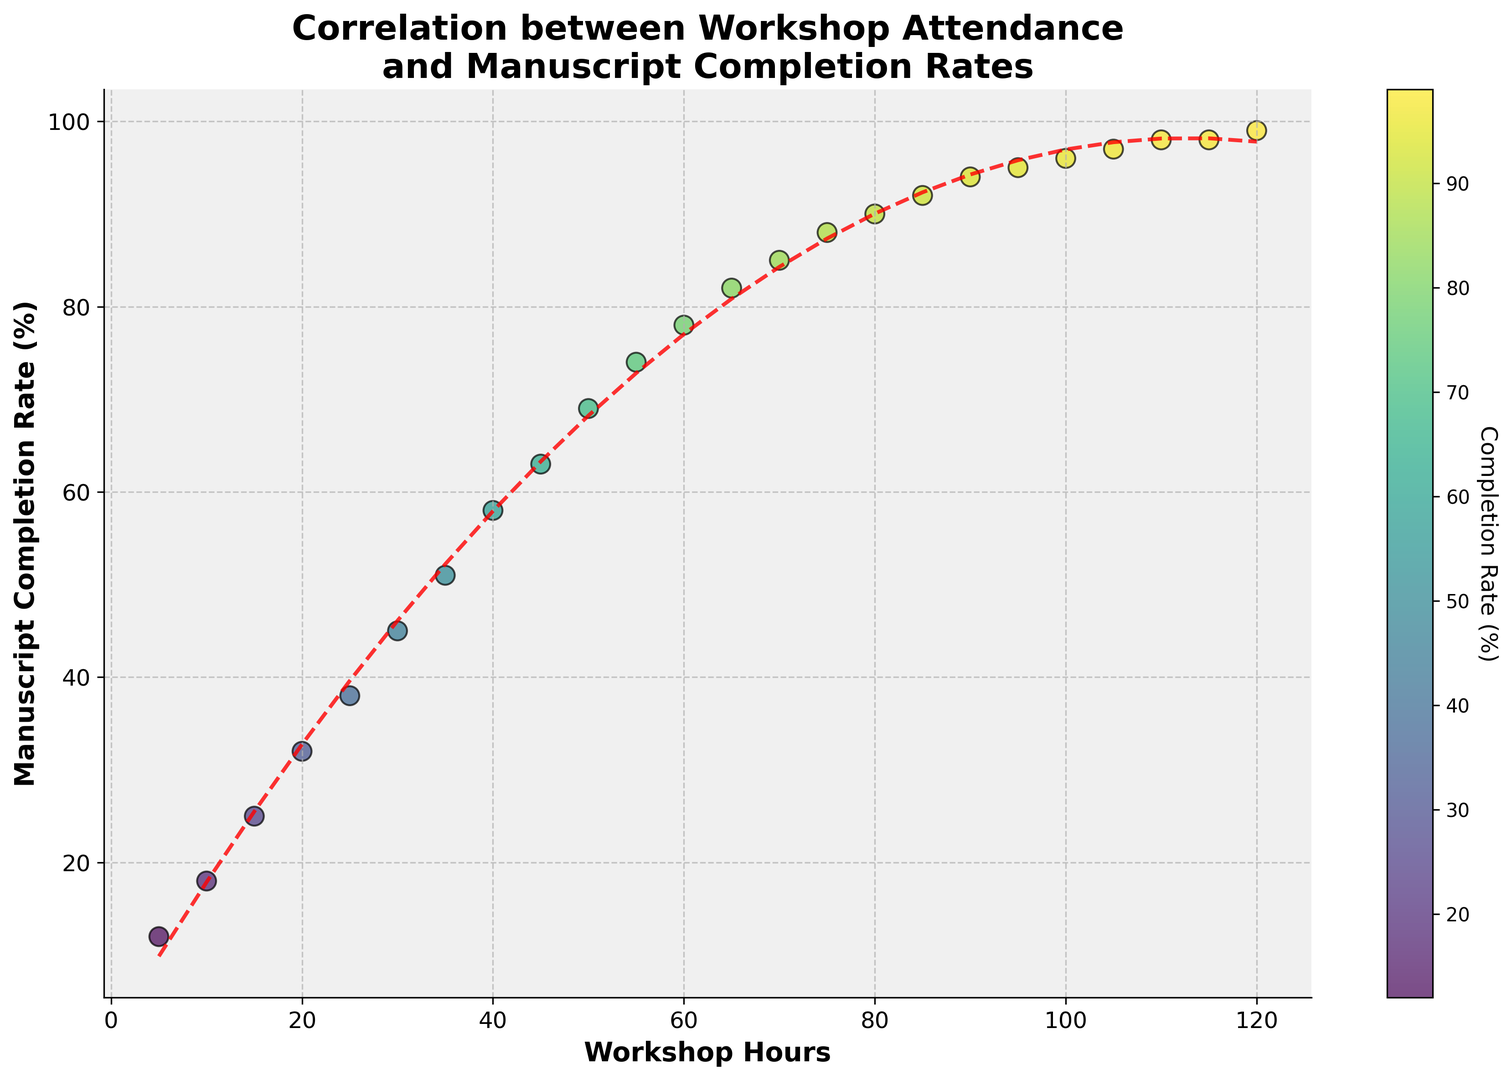What is the general trend shown in the scatter plot? The scatter plot shows that as workshop hours increase, the manuscript completion rate also increases. This is evidenced by the upward trend in both the scatter points and the fitted curve.
Answer: Positive correlation At what workshop hours does the manuscript completion rate first reach 90%? By looking at the scatter plot, the manuscript completion rate first reaches 90% at 80 workshop hours. This can be identified by finding the corresponding y-axis value on the graph.
Answer: 80 hours What is the difference in manuscript completion rates between attending 70 and 90 workshop hours? At 70 workshop hours, the completion rate is 85%, and at 90 hours, it is 94%. The difference is calculated by subtracting the two rates: 94% - 85% = 9%.
Answer: 9% How does the rate of increase in manuscript completion change as workshop hours increase? The increase in completion rates starts to slow down after a certain point, showing a diminishing return on additional workshop hours. This is evident from the flattening of the fitted curve as workshop hours exceed around 80-90 hours.
Answer: Slows down Which data point has the highest manuscript completion rate? The highest manuscript completion rate is 99%, which is achieved at 120 workshop hours. This can be found by identifying the highest y-value on the scatter plot.
Answer: 120 hours By attending an additional 60 hours of workshops, how much does the manuscript completion rate improve (from 5 to 65 hours)? At 5 hours, the completion rate is 12%. At 65 hours, it is 82%. The improvement is calculated by subtracting the two rates: 82% - 12% = 70%.
Answer: 70% Compare the manuscript completion rates at 25 hours and 75 hours of workshop attendance. Which one is higher and by how much? At 25 hours, the completion rate is 38%, and at 75 hours, it is 88%. The rate at 75 hours is higher by subtracting the two rates: 88% - 38% = 50%.
Answer: 75 hours by 50% What is the average manuscript completion rate for workshop hours ranging from 40 to 60? The completion rates for hours 40, 45, 50, 55, and 60 are 58%, 63%, 69%, 74%, and 78%, respectively. The average can be calculated as (58 + 63 + 69 + 74 + 78) / 5 = 68.4%.
Answer: 68.4% What happens to the manuscript completion rates as workshop hours increase beyond 100? Beyond 100 workshop hours, the manuscript completion rate increases very slowly and starts to plateau, as shown by the flattening curve on the scatter plot.
Answer: Plateaus How many workshop hours are required to achieve at least a 95% manuscript completion rate? Referring to the scatter plot, a manuscript completion rate of at least 95% is achieved at 95 workshop hours and beyond.
Answer: 95 hours 